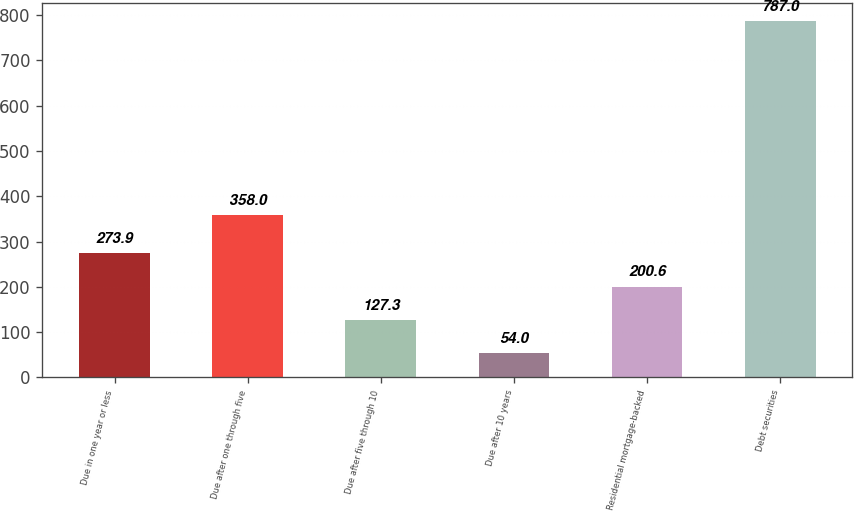Convert chart. <chart><loc_0><loc_0><loc_500><loc_500><bar_chart><fcel>Due in one year or less<fcel>Due after one through five<fcel>Due after five through 10<fcel>Due after 10 years<fcel>Residential mortgage-backed<fcel>Debt securities<nl><fcel>273.9<fcel>358<fcel>127.3<fcel>54<fcel>200.6<fcel>787<nl></chart> 